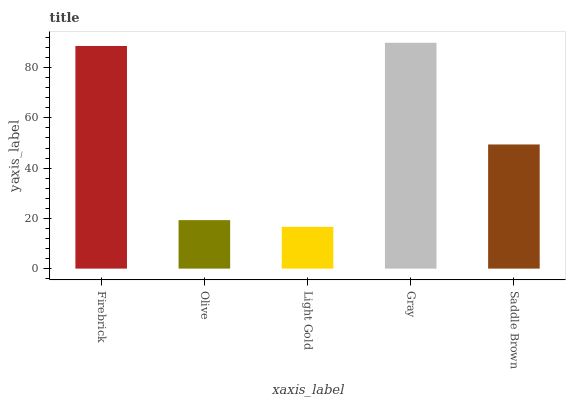Is Light Gold the minimum?
Answer yes or no. Yes. Is Gray the maximum?
Answer yes or no. Yes. Is Olive the minimum?
Answer yes or no. No. Is Olive the maximum?
Answer yes or no. No. Is Firebrick greater than Olive?
Answer yes or no. Yes. Is Olive less than Firebrick?
Answer yes or no. Yes. Is Olive greater than Firebrick?
Answer yes or no. No. Is Firebrick less than Olive?
Answer yes or no. No. Is Saddle Brown the high median?
Answer yes or no. Yes. Is Saddle Brown the low median?
Answer yes or no. Yes. Is Firebrick the high median?
Answer yes or no. No. Is Gray the low median?
Answer yes or no. No. 